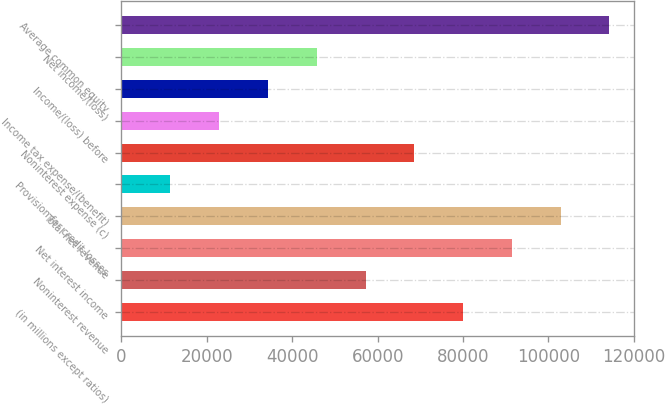Convert chart to OTSL. <chart><loc_0><loc_0><loc_500><loc_500><bar_chart><fcel>(in millions except ratios)<fcel>Noninterest revenue<fcel>Net interest income<fcel>Total net revenue<fcel>Provision for credit losses<fcel>Noninterest expense (c)<fcel>Income tax expense/(benefit)<fcel>Income/(loss) before<fcel>Net income/(loss)<fcel>Average common equity<nl><fcel>80021.6<fcel>57170<fcel>91447.4<fcel>102873<fcel>11466.8<fcel>68595.8<fcel>22892.6<fcel>34318.4<fcel>45744.2<fcel>114299<nl></chart> 